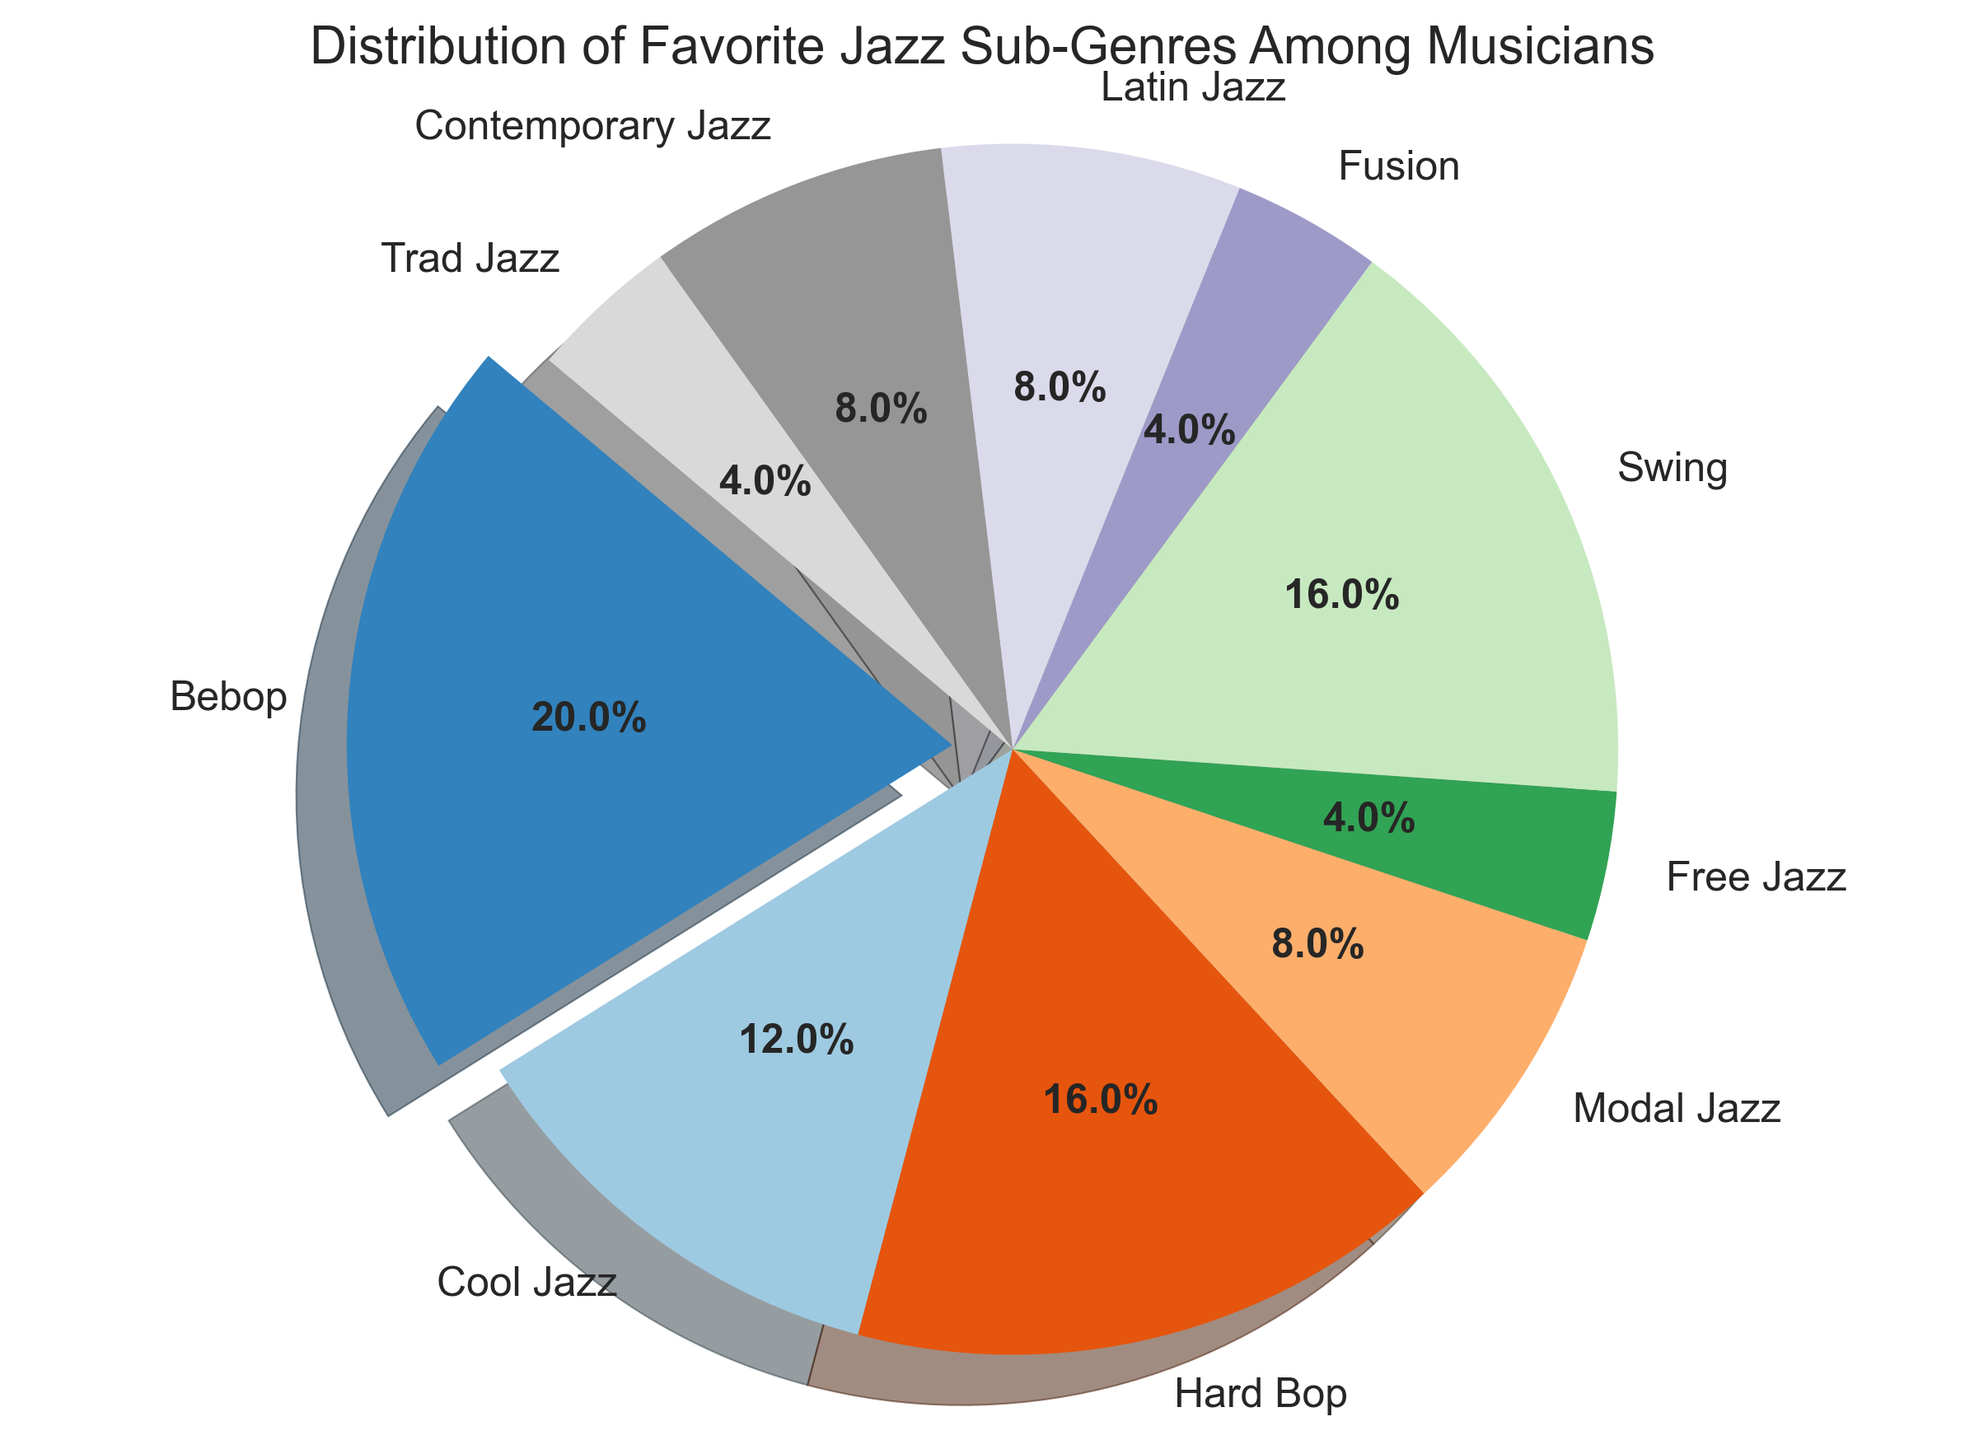Which jazz sub-genre has the highest number of musicians? By looking at the pie chart, the largest slice usually represents the sub-genre with the most musicians. The label indicates that Bebop has the highest percentage.
Answer: Bebop How many musicians in total prefer either Cool Jazz or Fusion? First, find the number of musicians for Cool Jazz (15) and Fusion (5). Then add them together: 15 + 5 = 20.
Answer: 20 Which two sub-genres have an equal number of musicians? Find the slices with the same percentage or size. In this chart, both Swing and Hard Bop have 20 musicians each, and Latin Jazz, Modal Jazz, and Contemporary Jazz each have 10 musicians.
Answer: Swing and Hard Bop; Latin Jazz, Modal Jazz, and Contemporary Jazz By how much does the number of musicians who prefer Bebop exceed those who prefer Free Jazz? Subtract the number of musicians who prefer Free Jazz (5) from those who prefer Bebop (25): 25 - 5 = 20.
Answer: 20 What percentage of musicians prefer Hard Bop or less popular sub-genres combined? Hard Bop has 20 musicians. Less popular sub-genres (Free Jazz, Fusion, Trad Jazz) each have 5 musicians. Sum these: 20 + 5 + 5 + 5 = 35. Calculate percentage: (35 / 125) * 100 = 28%.
Answer: 28% Which sub-genre has a slice with a distinctive color difference and is slightly "exploded" out of the pie? The "exploded" slice typically represents an attention-grabbing feature like the sub-genre with the highest number of musicians. Bebop has a distinctive color and is slightly exploded.
Answer: Bebop Is the number of musicians who prefer Modal Jazz greater than those who prefer Trad Jazz? Compare the two slices: Modal Jazz has 10 musicians, while Trad Jazz has 5. Hence, Modal Jazz is greater.
Answer: Yes What is the total number of musicians represented in the pie chart? Sum all the musicians from each sub-genre: 25 + 15 + 20 + 10 + 5 + 20 + 5 + 10 + 10 + 5 = 125.
Answer: 125 Which sub-genre has the most visually contrasting color in this pie chart? The largest slice, which is Bebop, typically uses a more contrasting color to highlight its prominence.
Answer: Bebop 